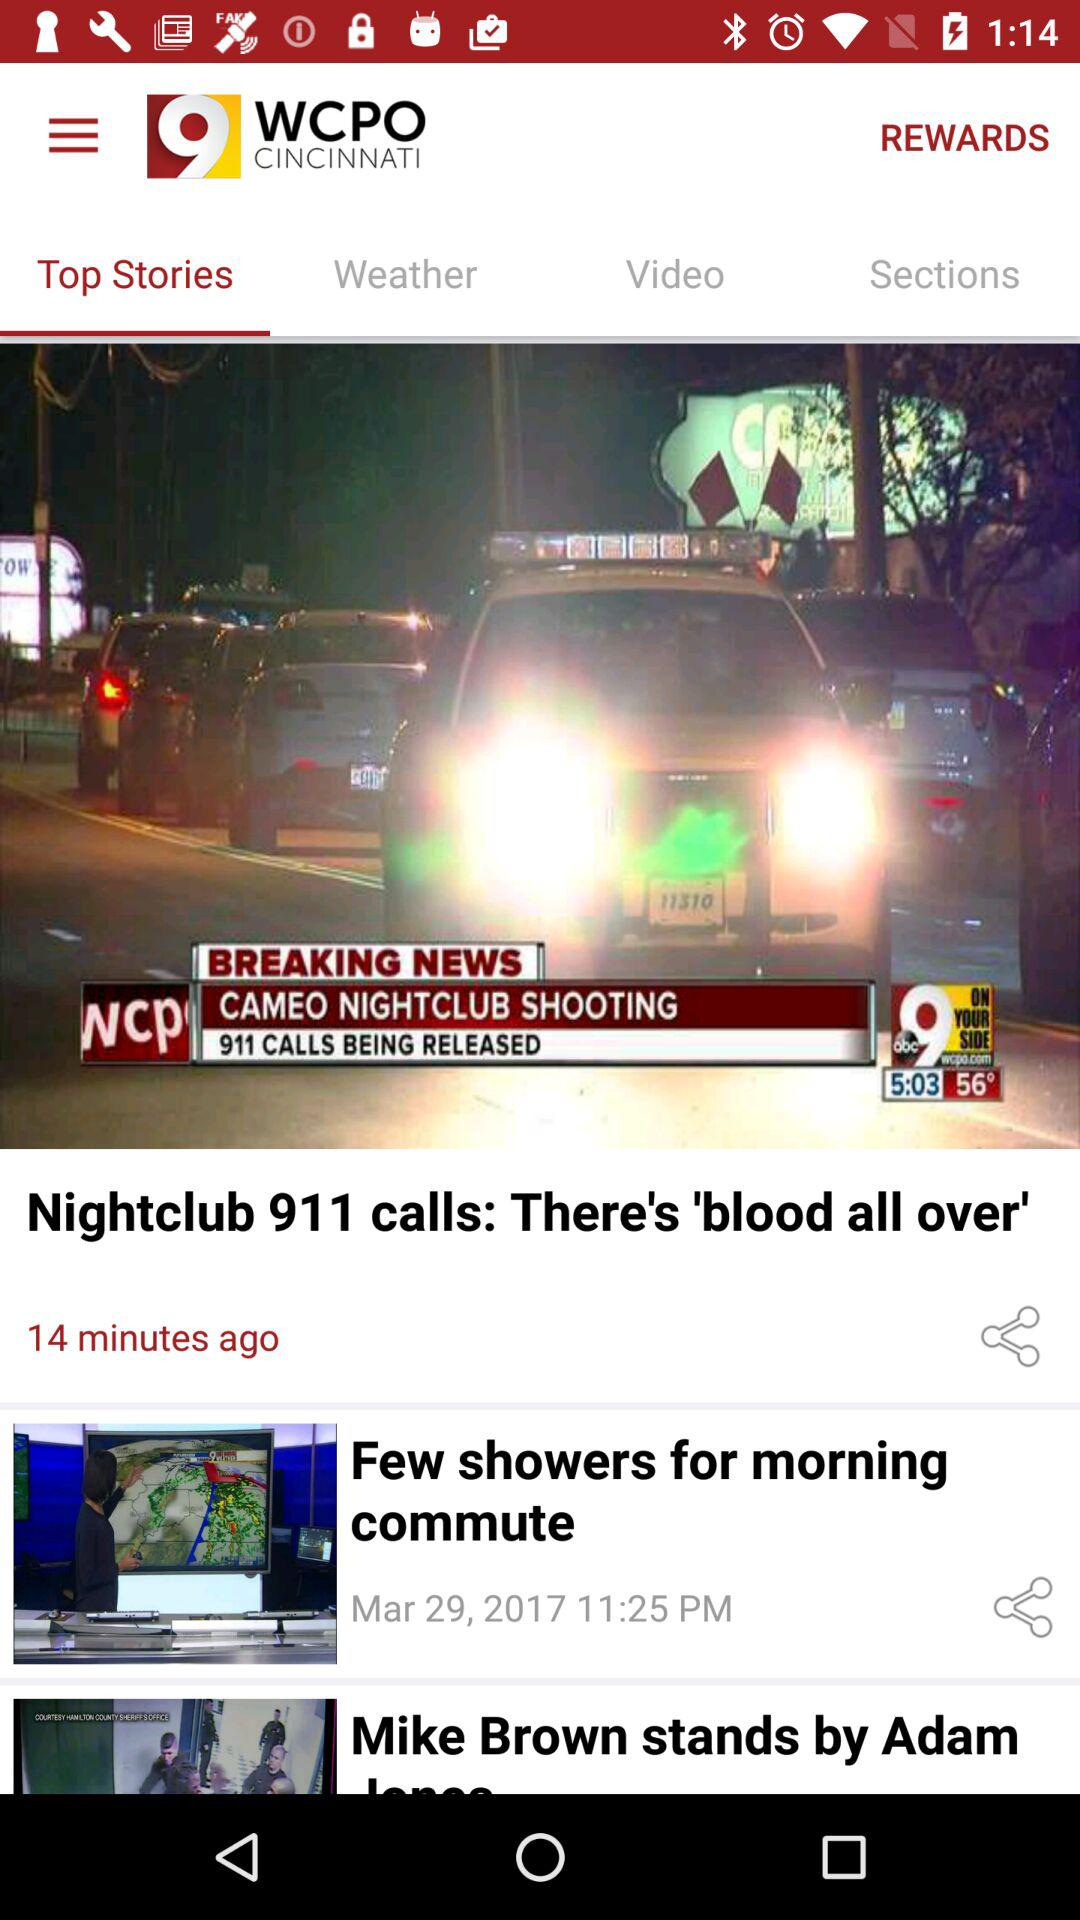What is the name of the application? The name of the application is "9 WCPO CINCINNATI". 